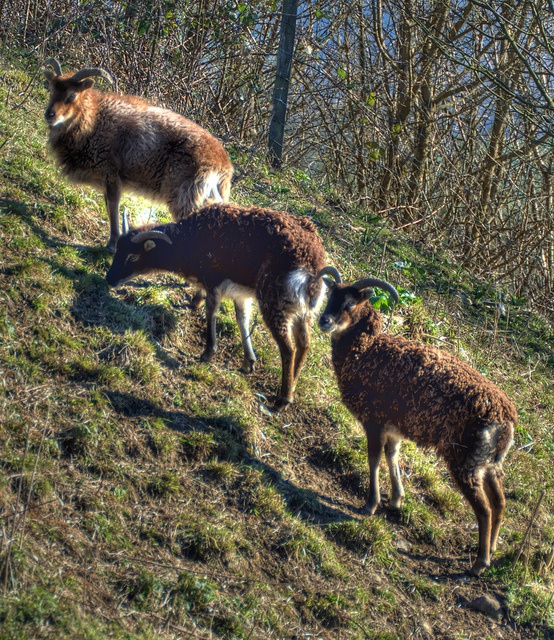Describe the objects in this image and their specific colors. I can see sheep in gray and black tones, sheep in gray, black, and tan tones, and sheep in gray and black tones in this image. 